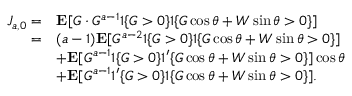<formula> <loc_0><loc_0><loc_500><loc_500>\begin{array} { r l } { J _ { a , 0 } = } & { E [ G \cdot G ^ { a - 1 } 1 \{ G > 0 \} 1 \{ G \cos \theta + W \sin \theta > 0 \} ] } \\ { = } & { ( a - 1 ) E [ G ^ { a - 2 } 1 \{ G > 0 \} 1 \{ G \cos \theta + W \sin \theta > 0 \} ] } \\ & { + E [ G ^ { a - 1 } 1 \{ G > 0 \} 1 ^ { \prime } \{ G \cos \theta + W \sin \theta > 0 \} ] \cos \theta } \\ & { + E [ G ^ { a - 1 } 1 ^ { \prime } \{ G > 0 \} 1 \{ G \cos \theta + W \sin \theta > 0 \} ] . } \end{array}</formula> 